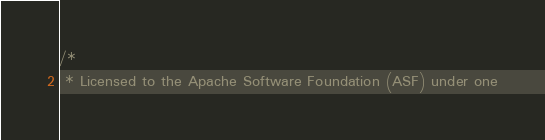Convert code to text. <code><loc_0><loc_0><loc_500><loc_500><_Cuda_>/*
 * Licensed to the Apache Software Foundation (ASF) under one</code> 